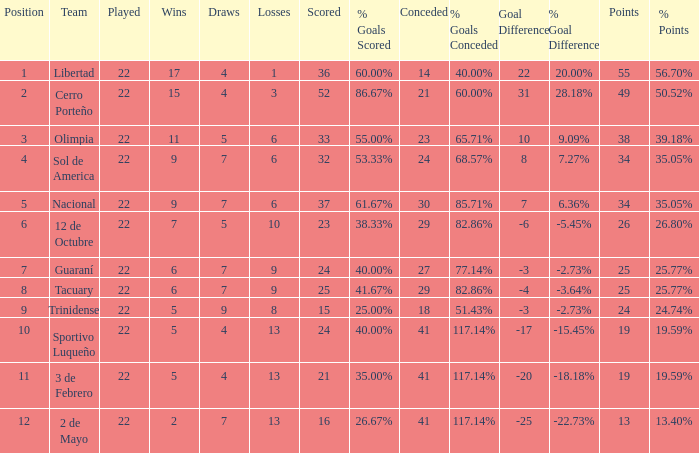What is the fewest wins that has fewer than 23 goals scored, team of 2 de Mayo, and fewer than 7 draws? None. 